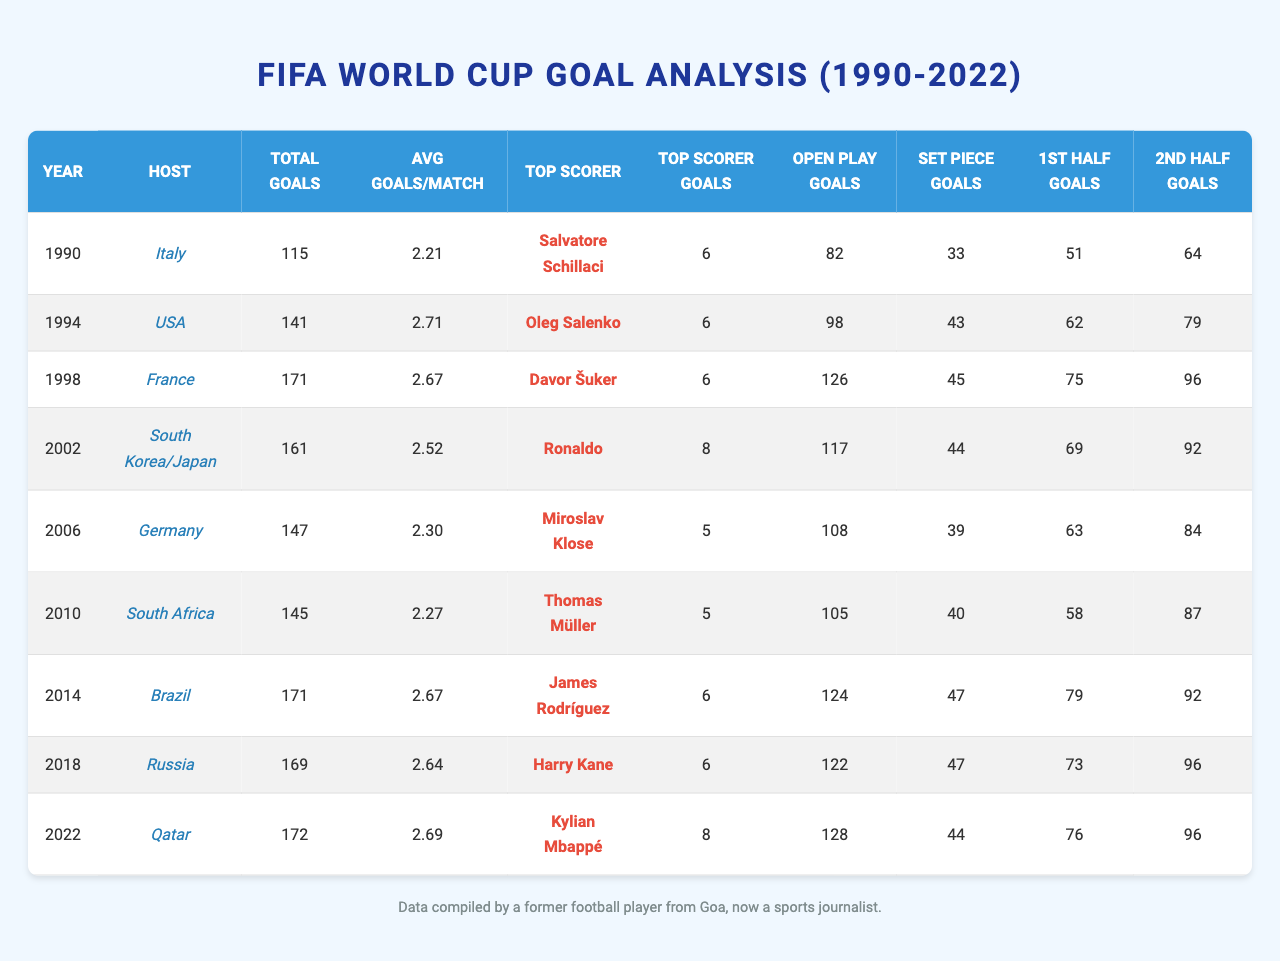What was the total number of goals scored in the 1994 FIFA World Cup? The table shows that the total number of goals scored in the 1994 tournament was 141.
Answer: 141 Who was the top scorer in the 2002 FIFA World Cup and how many goals did he score? According to the table, the top scorer in 2002 was Ronaldo, who scored 8 goals.
Answer: Ronaldo, 8 goals Which World Cup had the highest average goals per match, and what was the average? By examining the average goals per match, the 1994 World Cup had the highest average at 2.71 goals per match.
Answer: 1994, 2.71 How many goals were scored from set pieces in the 2010 FIFA World Cup? The table indicates that there were 40 goals scored from set pieces in the 2010 tournament.
Answer: 40 In which two tournaments did the top scorer score 6 goals? The data shows that the top scorer scored 6 goals in the World Cups of 1990, 1994, 2014, and 2018. Counting them gives us four tournaments.
Answer: 4 tournaments Did India qualify for any of the FIFA World Cups from 1990 to 2022? According to the qualification results in the table, India did not qualify for any of the World Cups during that period.
Answer: No What was the total number of goals scored in the first half versus the second half of the 2022 FIFA World Cup? The table lists that there were 76 goals scored in the first half and 96 in the second half during the 2022 tournament.
Answer: First half: 76, Second half: 96 What is the difference in total goals between the 1998 and 2006 FIFA World Cups? The total goals for 1998 were 171 and for 2006 were 147, so the difference is 171 - 147 = 24.
Answer: 24 Which tournament hosted by South Korea/Japan had the top scorer with the highest individual goals scored? The 2002 FIFA World Cup had Ronaldo as the top scorer with 8 goals, which is the highest individual tally among the tournaments hosted by South Korea and Japan.
Answer: 2002, Ronaldo, 8 goals How many total goals from open play were scored across all tournaments in the table? Adding the open play goals from each tournament (82 + 98 + 126 + 117 + 108 + 105 + 124 + 122 + 128) gives a total of 1,015 goals from open play.
Answer: 1,015 